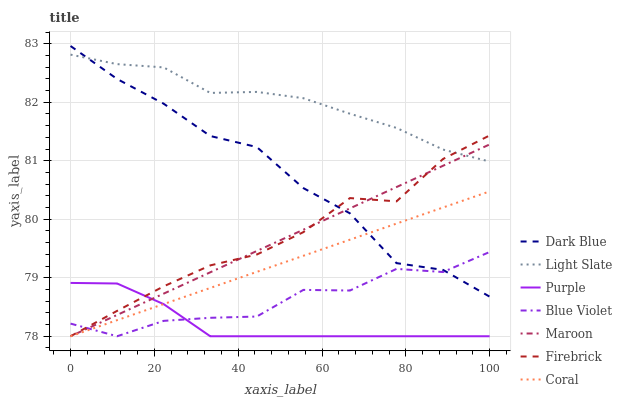Does Purple have the minimum area under the curve?
Answer yes or no. Yes. Does Light Slate have the maximum area under the curve?
Answer yes or no. Yes. Does Firebrick have the minimum area under the curve?
Answer yes or no. No. Does Firebrick have the maximum area under the curve?
Answer yes or no. No. Is Coral the smoothest?
Answer yes or no. Yes. Is Dark Blue the roughest?
Answer yes or no. Yes. Is Light Slate the smoothest?
Answer yes or no. No. Is Light Slate the roughest?
Answer yes or no. No. Does Light Slate have the lowest value?
Answer yes or no. No. Does Dark Blue have the highest value?
Answer yes or no. Yes. Does Light Slate have the highest value?
Answer yes or no. No. Is Coral less than Light Slate?
Answer yes or no. Yes. Is Light Slate greater than Blue Violet?
Answer yes or no. Yes. Does Purple intersect Blue Violet?
Answer yes or no. Yes. Is Purple less than Blue Violet?
Answer yes or no. No. Is Purple greater than Blue Violet?
Answer yes or no. No. Does Coral intersect Light Slate?
Answer yes or no. No. 